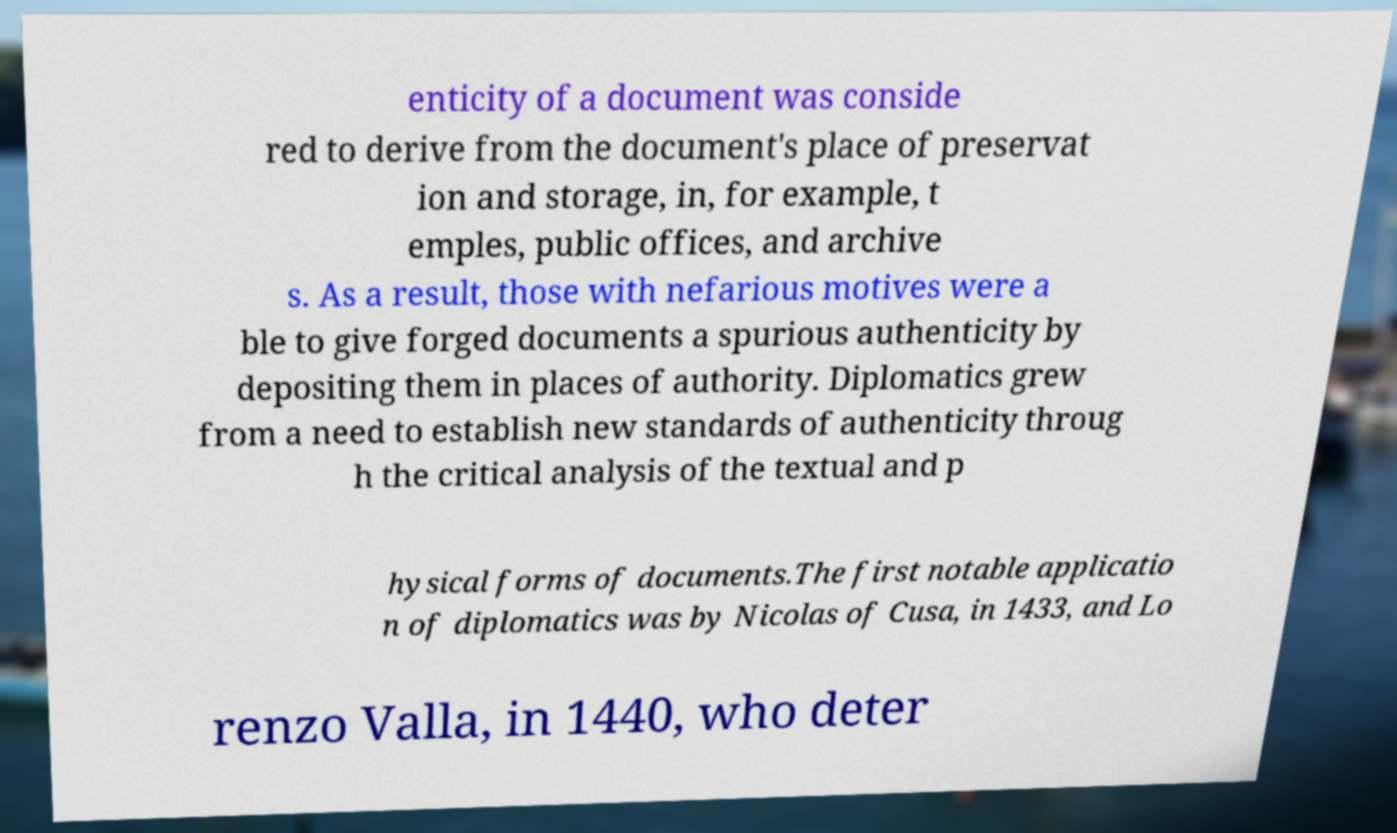What messages or text are displayed in this image? I need them in a readable, typed format. enticity of a document was conside red to derive from the document's place of preservat ion and storage, in, for example, t emples, public offices, and archive s. As a result, those with nefarious motives were a ble to give forged documents a spurious authenticity by depositing them in places of authority. Diplomatics grew from a need to establish new standards of authenticity throug h the critical analysis of the textual and p hysical forms of documents.The first notable applicatio n of diplomatics was by Nicolas of Cusa, in 1433, and Lo renzo Valla, in 1440, who deter 